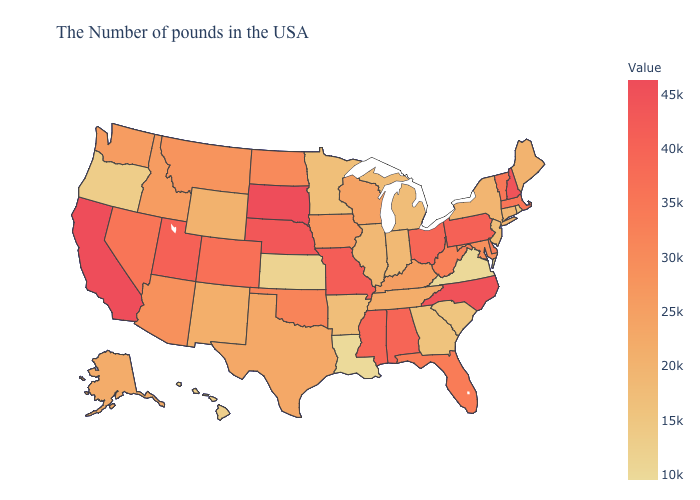Does Rhode Island have the lowest value in the Northeast?
Answer briefly. Yes. Does Colorado have a higher value than Nebraska?
Write a very short answer. No. Does Idaho have the highest value in the West?
Give a very brief answer. No. Does Nebraska have the lowest value in the USA?
Short answer required. No. 